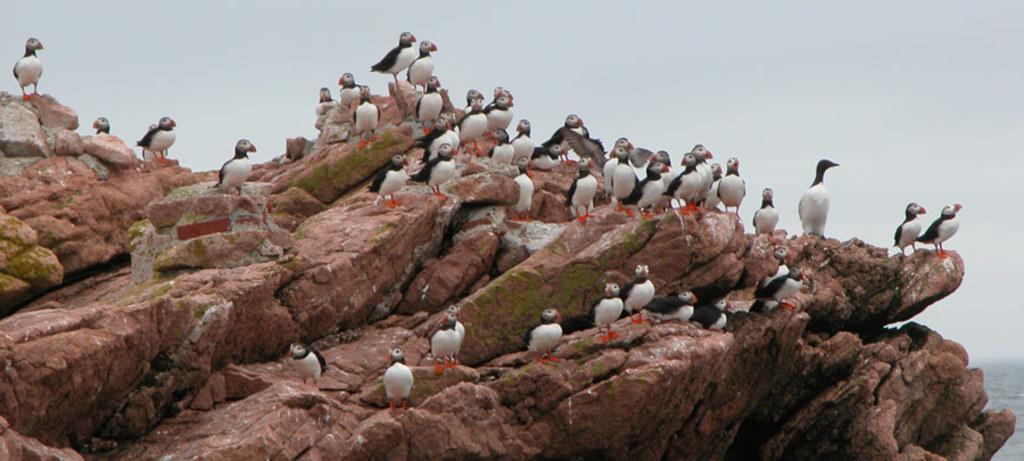Describe this image in one or two sentences. In this image I can see the hill, on the hill I can see group of birds and at the top I can see the sky. 